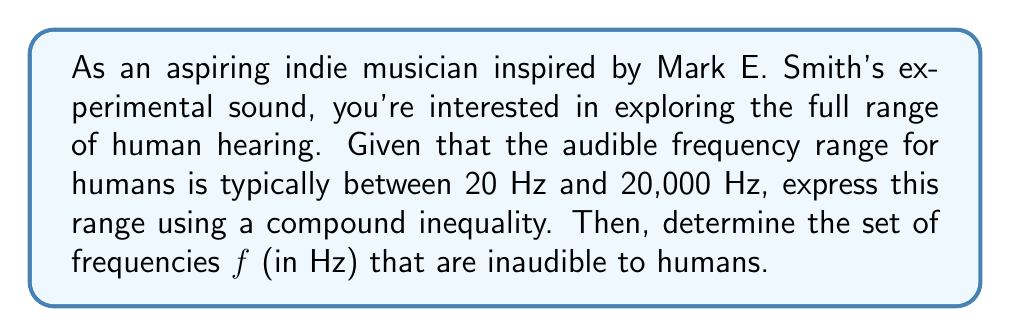Could you help me with this problem? Let's approach this step-by-step:

1) The human audible range can be expressed as a compound inequality:

   $$ 20 \leq f \leq 20000 $$

   Where $f$ represents the frequency in Hz.

2) To find the inaudible frequencies, we need to consider what's outside this range. This means frequencies below 20 Hz and above 20,000 Hz.

3) We can express this mathematically as:

   $$ f < 20 \quad \text{or} \quad f > 20000 $$

4) In interval notation, this can be written as:

   $$ (-\infty, 20) \cup (20000, \infty) $$

5) This represents all frequencies below 20 Hz (which includes infrasound, often used in experimental music) and above 20,000 Hz (which includes ultrasound).

Note: In reality, the upper limit of human hearing decreases with age, and some individuals might hear slightly outside this range. However, for general purposes, this is the accepted range.
Answer: The set of frequencies $f$ (in Hz) that are inaudible to humans can be expressed as:

$$ f < 20 \quad \text{or} \quad f > 20000 $$

Or in interval notation:

$$ (-\infty, 20) \cup (20000, \infty) $$ 